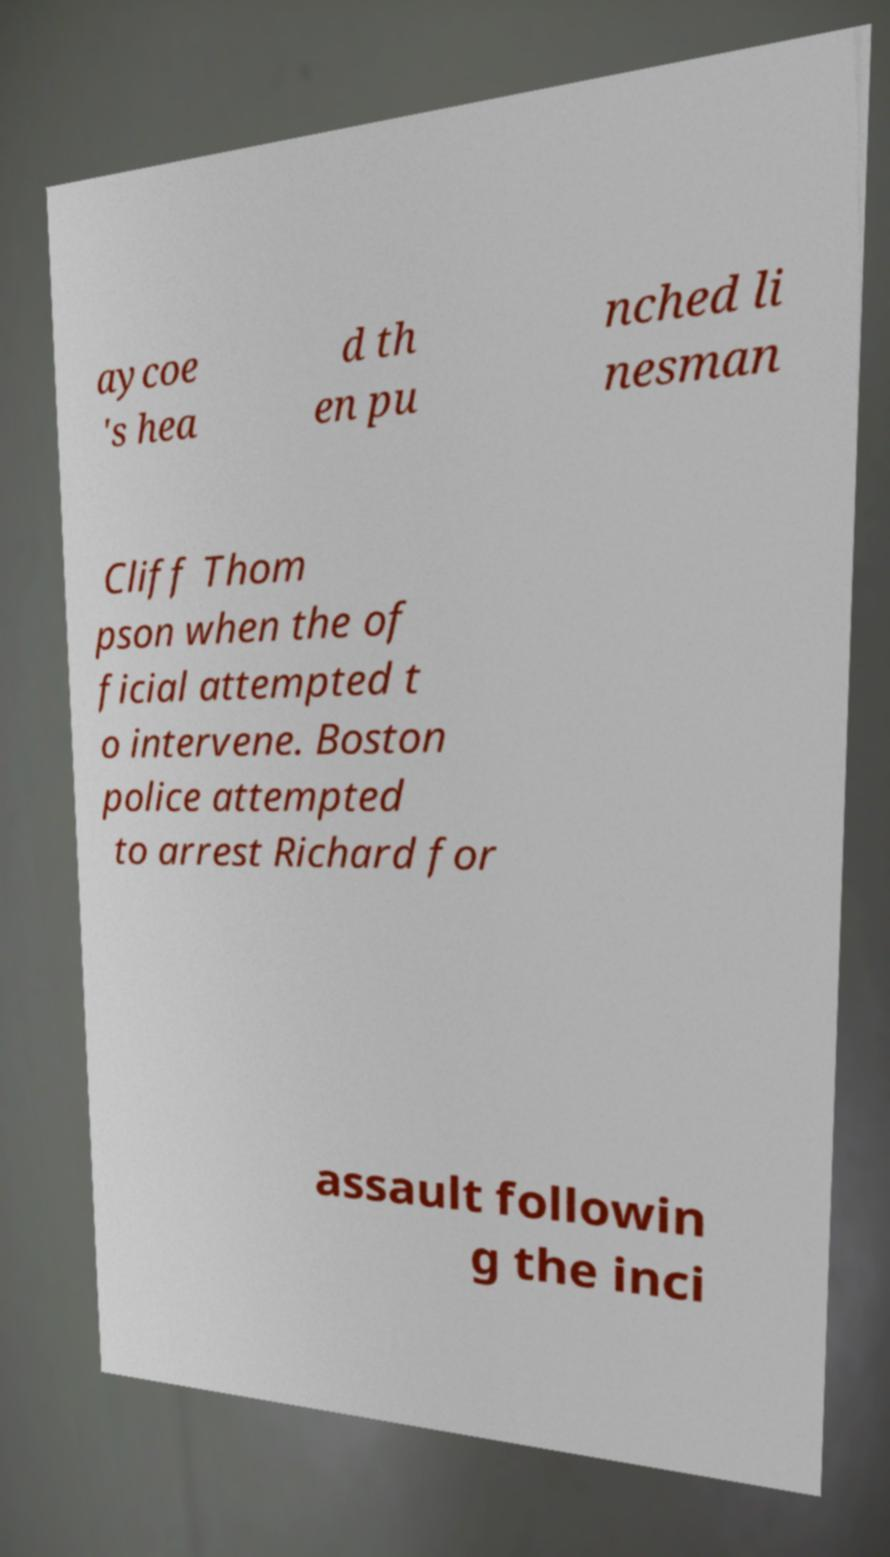There's text embedded in this image that I need extracted. Can you transcribe it verbatim? aycoe 's hea d th en pu nched li nesman Cliff Thom pson when the of ficial attempted t o intervene. Boston police attempted to arrest Richard for assault followin g the inci 